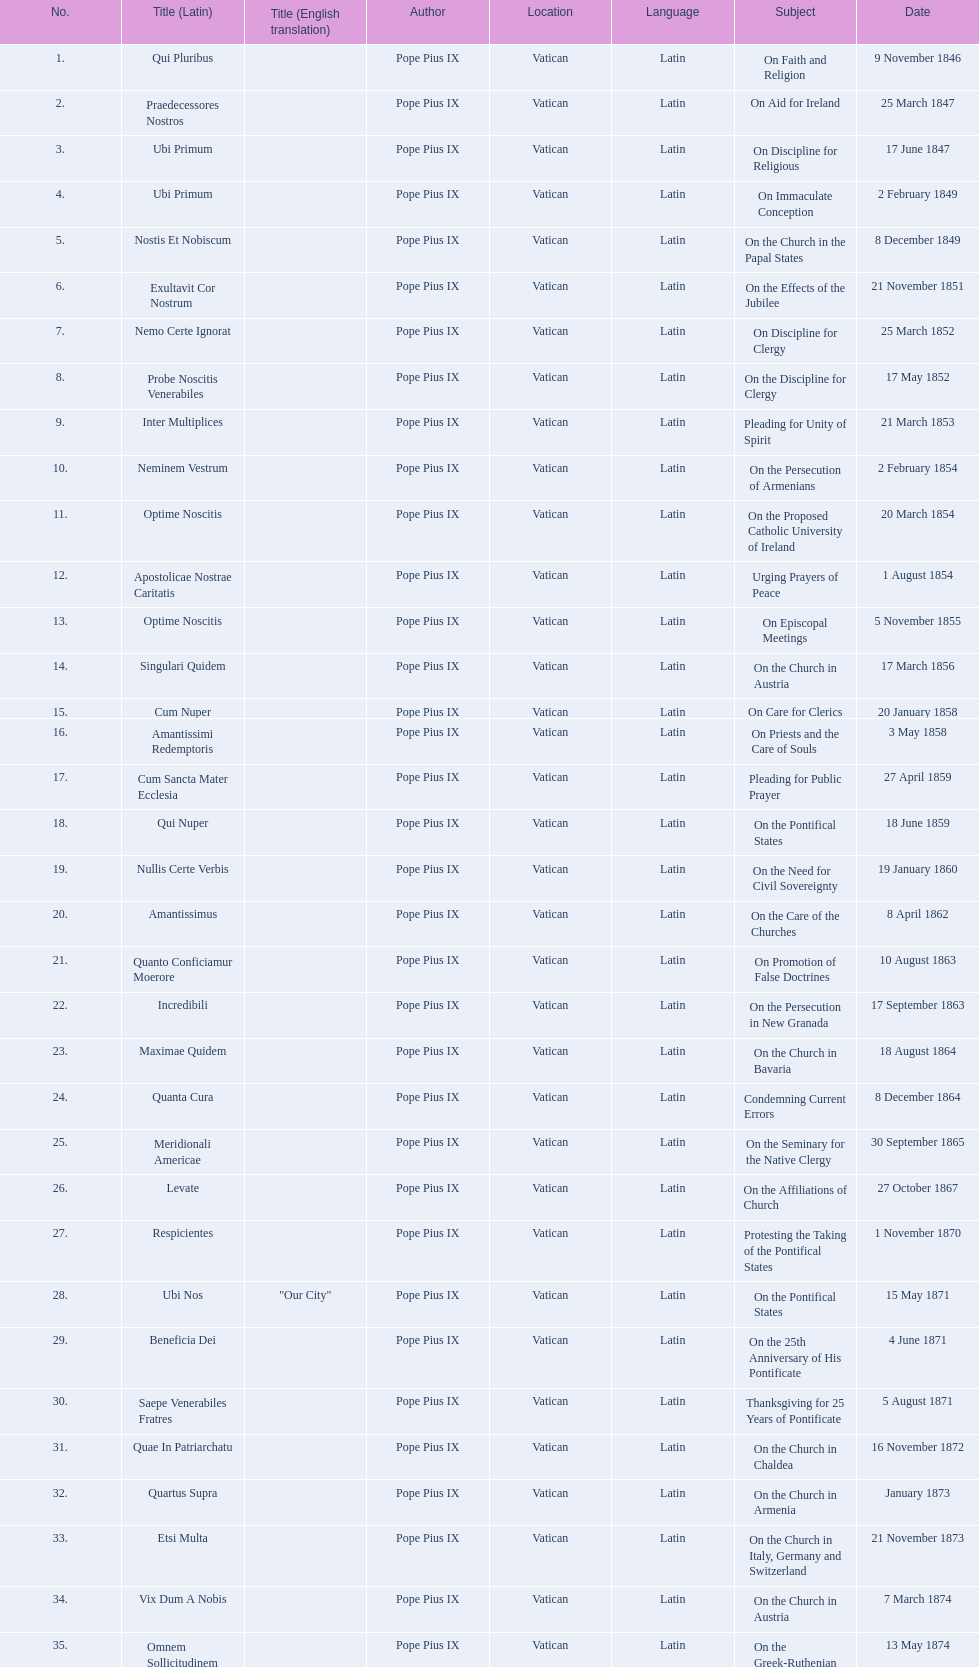What is the total number of title? 38. Could you parse the entire table as a dict? {'header': ['No.', 'Title (Latin)', 'Title (English translation)', 'Author', 'Location', 'Language', 'Subject', 'Date'], 'rows': [['1.', 'Qui Pluribus', '', 'Pope Pius IX', 'Vatican', 'Latin', 'On Faith and Religion', '9 November 1846'], ['2.', 'Praedecessores Nostros', '', 'Pope Pius IX', 'Vatican', 'Latin', 'On Aid for Ireland', '25 March 1847'], ['3.', 'Ubi Primum', '', 'Pope Pius IX', 'Vatican', 'Latin', 'On Discipline for Religious', '17 June 1847'], ['4.', 'Ubi Primum', '', 'Pope Pius IX', 'Vatican', 'Latin', 'On Immaculate Conception', '2 February 1849'], ['5.', 'Nostis Et Nobiscum', '', 'Pope Pius IX', 'Vatican', 'Latin', 'On the Church in the Papal States', '8 December 1849'], ['6.', 'Exultavit Cor Nostrum', '', 'Pope Pius IX', 'Vatican', 'Latin', 'On the Effects of the Jubilee', '21 November 1851'], ['7.', 'Nemo Certe Ignorat', '', 'Pope Pius IX', 'Vatican', 'Latin', 'On Discipline for Clergy', '25 March 1852'], ['8.', 'Probe Noscitis Venerabiles', '', 'Pope Pius IX', 'Vatican', 'Latin', 'On the Discipline for Clergy', '17 May 1852'], ['9.', 'Inter Multiplices', '', 'Pope Pius IX', 'Vatican', 'Latin', 'Pleading for Unity of Spirit', '21 March 1853'], ['10.', 'Neminem Vestrum', '', 'Pope Pius IX', 'Vatican', 'Latin', 'On the Persecution of Armenians', '2 February 1854'], ['11.', 'Optime Noscitis', '', 'Pope Pius IX', 'Vatican', 'Latin', 'On the Proposed Catholic University of Ireland', '20 March 1854'], ['12.', 'Apostolicae Nostrae Caritatis', '', 'Pope Pius IX', 'Vatican', 'Latin', 'Urging Prayers of Peace', '1 August 1854'], ['13.', 'Optime Noscitis', '', 'Pope Pius IX', 'Vatican', 'Latin', 'On Episcopal Meetings', '5 November 1855'], ['14.', 'Singulari Quidem', '', 'Pope Pius IX', 'Vatican', 'Latin', 'On the Church in Austria', '17 March 1856'], ['15.', 'Cum Nuper', '', 'Pope Pius IX', 'Vatican', 'Latin', 'On Care for Clerics', '20 January 1858'], ['16.', 'Amantissimi Redemptoris', '', 'Pope Pius IX', 'Vatican', 'Latin', 'On Priests and the Care of Souls', '3 May 1858'], ['17.', 'Cum Sancta Mater Ecclesia', '', 'Pope Pius IX', 'Vatican', 'Latin', 'Pleading for Public Prayer', '27 April 1859'], ['18.', 'Qui Nuper', '', 'Pope Pius IX', 'Vatican', 'Latin', 'On the Pontifical States', '18 June 1859'], ['19.', 'Nullis Certe Verbis', '', 'Pope Pius IX', 'Vatican', 'Latin', 'On the Need for Civil Sovereignty', '19 January 1860'], ['20.', 'Amantissimus', '', 'Pope Pius IX', 'Vatican', 'Latin', 'On the Care of the Churches', '8 April 1862'], ['21.', 'Quanto Conficiamur Moerore', '', 'Pope Pius IX', 'Vatican', 'Latin', 'On Promotion of False Doctrines', '10 August 1863'], ['22.', 'Incredibili', '', 'Pope Pius IX', 'Vatican', 'Latin', 'On the Persecution in New Granada', '17 September 1863'], ['23.', 'Maximae Quidem', '', 'Pope Pius IX', 'Vatican', 'Latin', 'On the Church in Bavaria', '18 August 1864'], ['24.', 'Quanta Cura', '', 'Pope Pius IX', 'Vatican', 'Latin', 'Condemning Current Errors', '8 December 1864'], ['25.', 'Meridionali Americae', '', 'Pope Pius IX', 'Vatican', 'Latin', 'On the Seminary for the Native Clergy', '30 September 1865'], ['26.', 'Levate', '', 'Pope Pius IX', 'Vatican', 'Latin', 'On the Affiliations of Church', '27 October 1867'], ['27.', 'Respicientes', '', 'Pope Pius IX', 'Vatican', 'Latin', 'Protesting the Taking of the Pontifical States', '1 November 1870'], ['28.', 'Ubi Nos', '"Our City"', 'Pope Pius IX', 'Vatican', 'Latin', 'On the Pontifical States', '15 May 1871'], ['29.', 'Beneficia Dei', '', 'Pope Pius IX', 'Vatican', 'Latin', 'On the 25th Anniversary of His Pontificate', '4 June 1871'], ['30.', 'Saepe Venerabiles Fratres', '', 'Pope Pius IX', 'Vatican', 'Latin', 'Thanksgiving for 25 Years of Pontificate', '5 August 1871'], ['31.', 'Quae In Patriarchatu', '', 'Pope Pius IX', 'Vatican', 'Latin', 'On the Church in Chaldea', '16 November 1872'], ['32.', 'Quartus Supra', '', 'Pope Pius IX', 'Vatican', 'Latin', 'On the Church in Armenia', 'January 1873'], ['33.', 'Etsi Multa', '', 'Pope Pius IX', 'Vatican', 'Latin', 'On the Church in Italy, Germany and Switzerland', '21 November 1873'], ['34.', 'Vix Dum A Nobis', '', 'Pope Pius IX', 'Vatican', 'Latin', 'On the Church in Austria', '7 March 1874'], ['35.', 'Omnem Sollicitudinem', '', 'Pope Pius IX', 'Vatican', 'Latin', 'On the Greek-Ruthenian Rite', '13 May 1874'], ['36.', 'Gravibus Ecclesiae', '', 'Pope Pius IX', 'Vatican', 'Latin', 'Proclaiming A Jubilee', '24 December 1874'], ['37.', 'Quod Nunquam', '', 'Pope Pius IX', 'Vatican', 'Latin', 'On the Church in Prussia', '5 February 1875'], ['38.', 'Graves Ac Diuturnae', '', 'Pope Pius IX', 'Vatican', 'Latin', 'On the Church in Switzerland', '23 March 1875']]} 